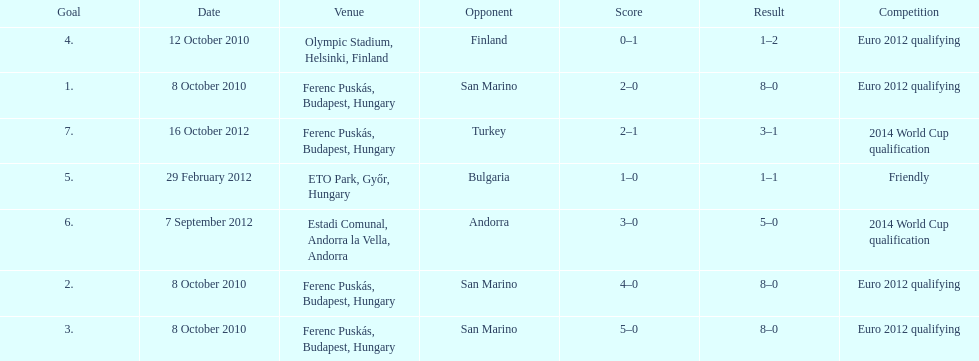In what year did ádám szalai make his next international goal after 2010? 2012. 